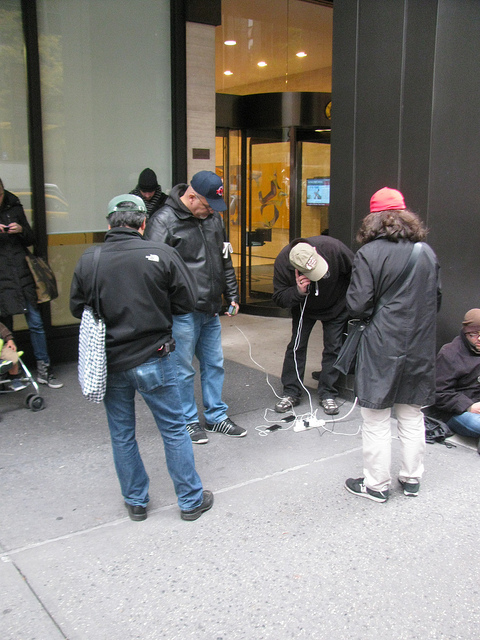What are the people in the picture doing? The people in the image appear to be attending to a task on the ground, possibly related to electrical work given the visible wires and equipment. They seem focused and engaged in problem-solving. Is it a busy location? Yes, the background suggests this activity is happening in a bustling urban area, possibly near an office or a business establishment, indicated by the glass door and pavement. 